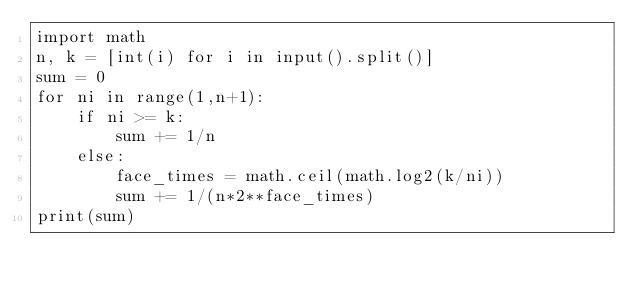<code> <loc_0><loc_0><loc_500><loc_500><_Python_>import math
n, k = [int(i) for i in input().split()]
sum = 0
for ni in range(1,n+1):
    if ni >= k:
        sum += 1/n
    else:
        face_times = math.ceil(math.log2(k/ni))
        sum += 1/(n*2**face_times)
print(sum)</code> 